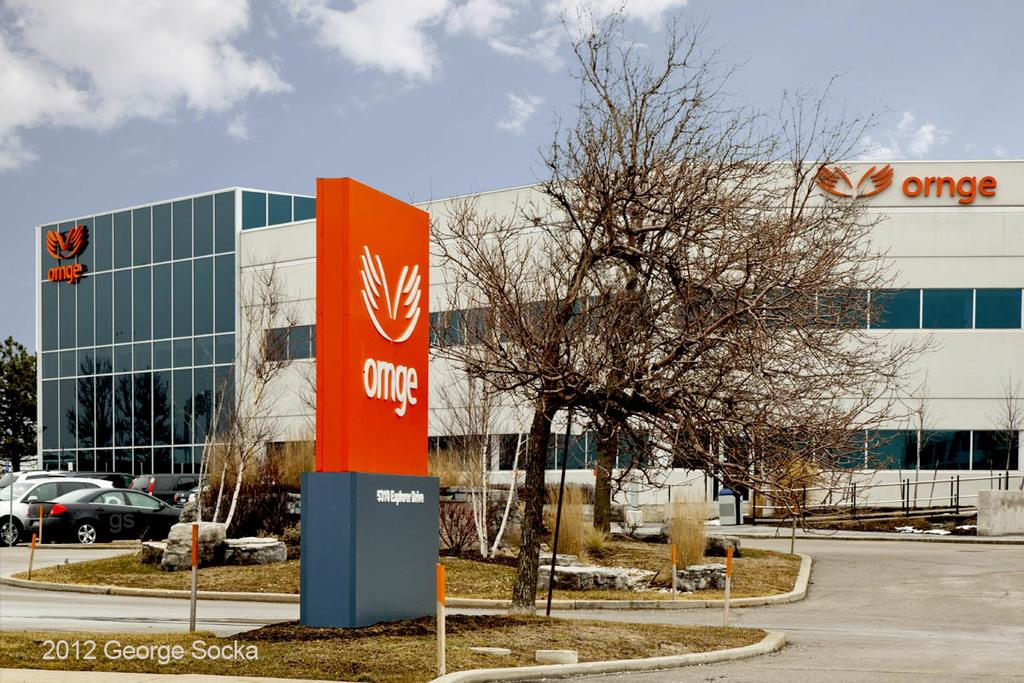What type of structure is in the image? There is a building in the image. What is located in front of the building? Vehicles are visible in front of the building. What are the poles used for in the image? The purpose of the poles is not specified, but they are present in the image. What type of pathway is in the image? There is a road in the image. What are the boards used for in the image? The purpose of the boards is not specified, but they are visible in the image. What type of vegetation is in the image? Trees are present in the image. What is visible at the top of the image? The sky is visible at the top of the image. What caption is written on the building in the image? There is no caption visible on the building in the image. What shape is the territory in the image? There is no territory present in the image; it is a scene featuring a building, vehicles, poles, a road, boards, trees, and the sky. 